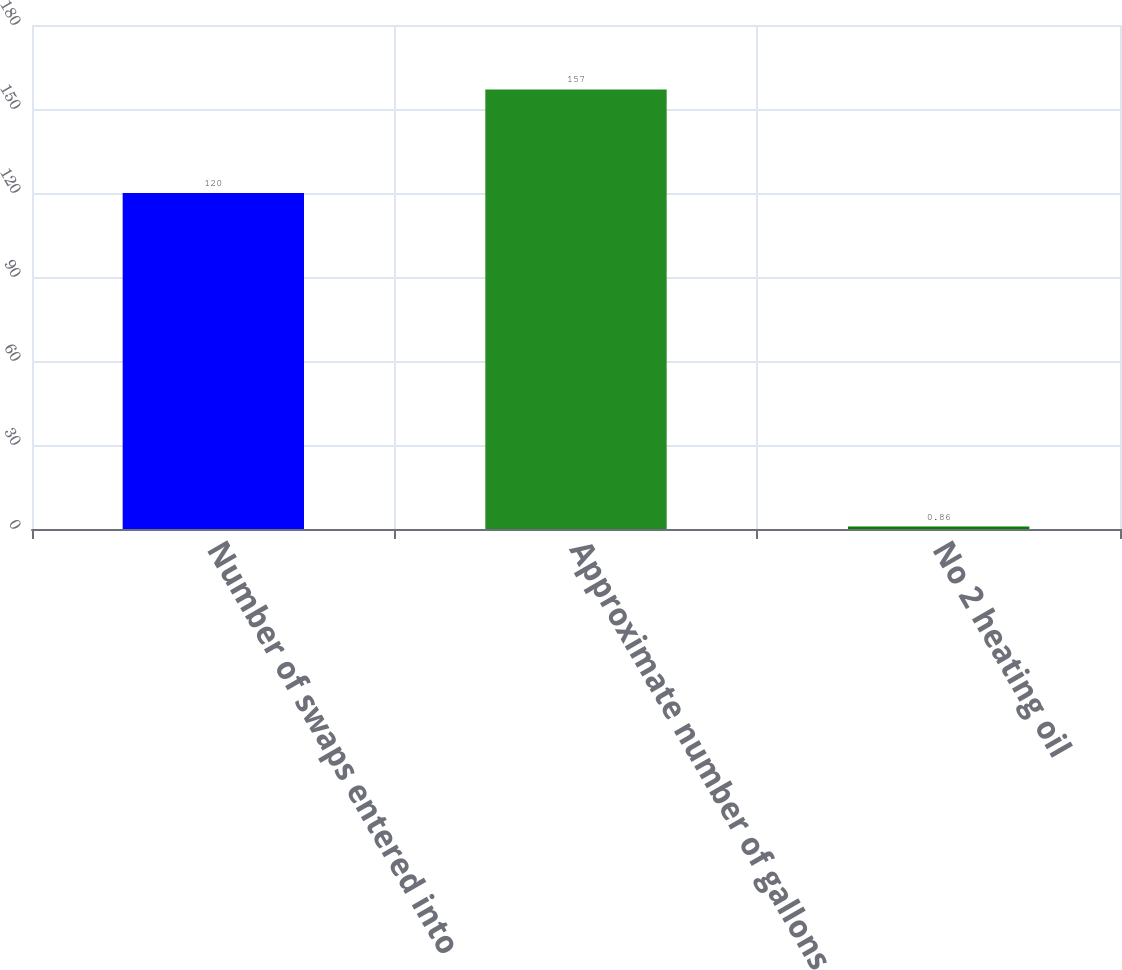<chart> <loc_0><loc_0><loc_500><loc_500><bar_chart><fcel>Number of swaps entered into<fcel>Approximate number of gallons<fcel>No 2 heating oil<nl><fcel>120<fcel>157<fcel>0.86<nl></chart> 